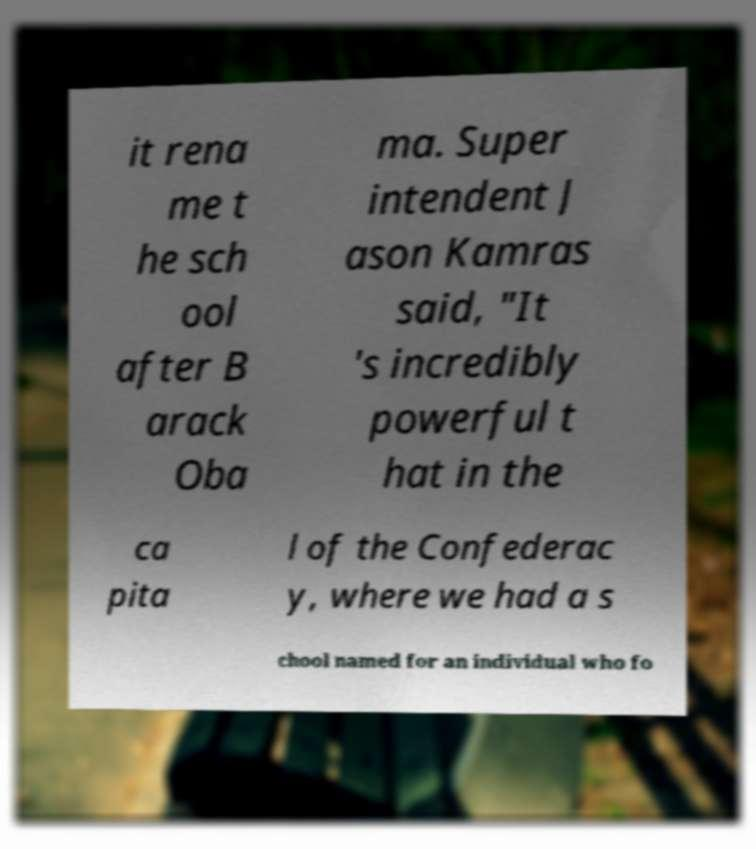Could you assist in decoding the text presented in this image and type it out clearly? it rena me t he sch ool after B arack Oba ma. Super intendent J ason Kamras said, "It 's incredibly powerful t hat in the ca pita l of the Confederac y, where we had a s chool named for an individual who fo 